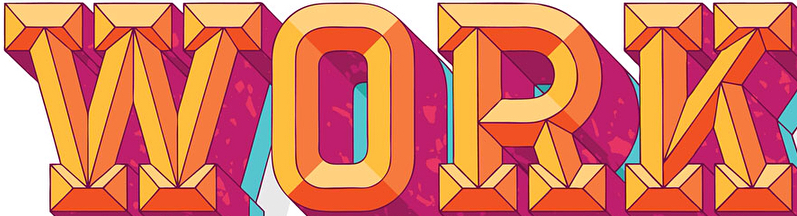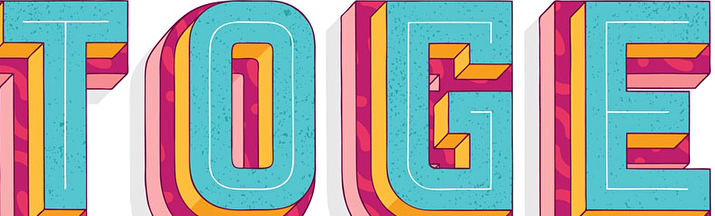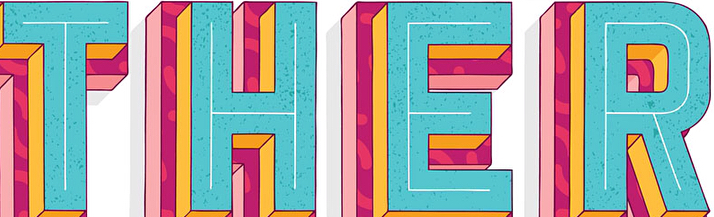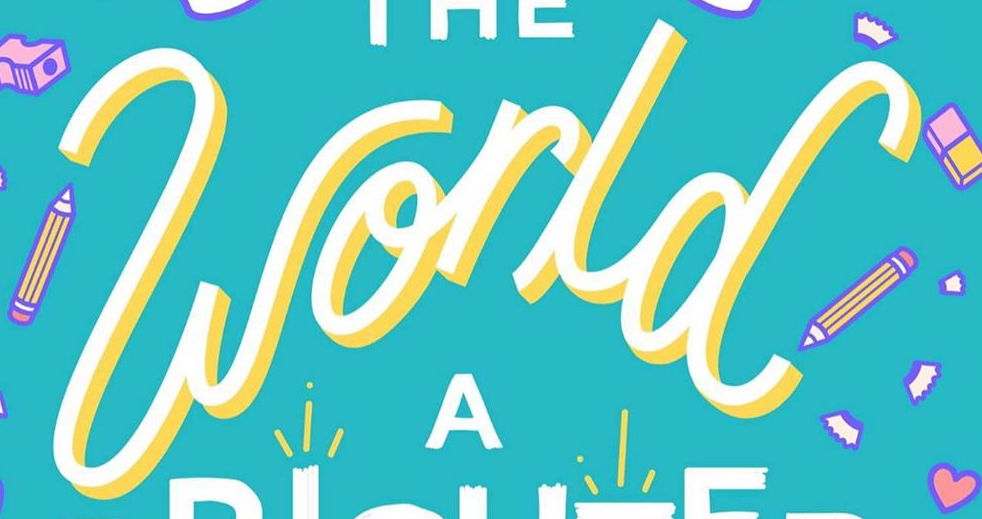Read the text from these images in sequence, separated by a semicolon. WORK; TOGE; THER; world 